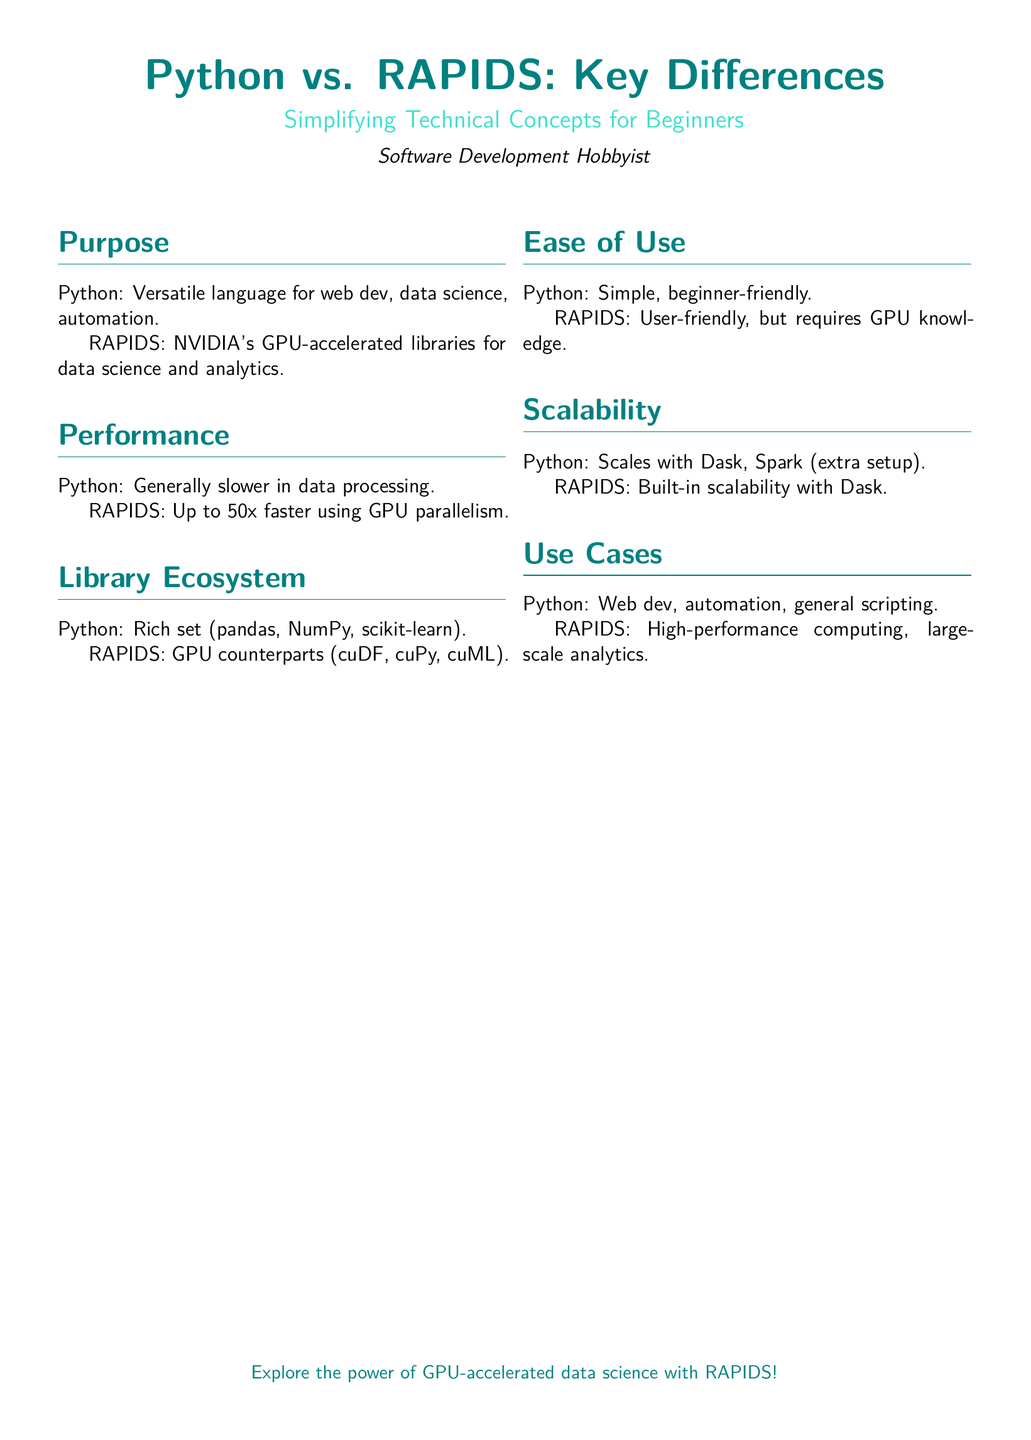What is the purpose of Python? The document states that Python is a versatile language for web development, data science, and automation.
Answer: Versatile language for web dev, data science, automation What is the performance advantage of RAPIDS? According to the document, RAPIDS is up to 50x faster using GPU parallelism.
Answer: Up to 50x faster What are the GPU counterparts of pandas in RAPIDS? The document mentions cuDF as the GPU counterpart of pandas.
Answer: cuDF What type of scalability does RAPIDS offer? The document indicates that RAPIDS has built-in scalability with Dask.
Answer: Built-in scalability with Dask What is one key use case for RAPIDS? The document lists high-performance computing as a key use case for RAPIDS.
Answer: High-performance computing Which library ecosystem does Python offer? The document states that Python has a rich set of libraries such as pandas, NumPy, and scikit-learn.
Answer: Rich set (pandas, NumPy, scikit-learn) Does RAPIDS require knowledge of GPUs? The document notes that RAPIDS is user-friendly but requires GPU knowledge.
Answer: Requires GPU knowledge What color is used for the title in the document? The document specifies that the main color for the title is a shade of teal.
Answer: Maincolor (teal) 